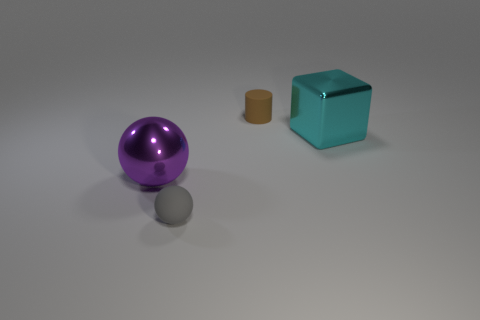Is there any other thing that is the same shape as the brown rubber thing?
Keep it short and to the point. No. What number of gray balls are in front of the big cyan metallic object?
Provide a succinct answer. 1. Is the number of big things in front of the large purple object less than the number of big balls?
Provide a succinct answer. Yes. What color is the big shiny block?
Make the answer very short. Cyan. The other metallic thing that is the same shape as the gray object is what color?
Ensure brevity in your answer.  Purple. How many small objects are either yellow things or cyan metal blocks?
Provide a short and direct response. 0. There is a matte thing that is on the left side of the rubber cylinder; how big is it?
Your response must be concise. Small. How many big shiny objects are to the left of the matte ball that is right of the purple thing?
Provide a succinct answer. 1. How many purple things are made of the same material as the tiny ball?
Make the answer very short. 0. There is a small ball; are there any balls behind it?
Ensure brevity in your answer.  Yes. 